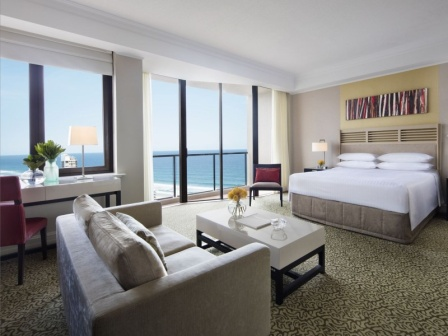Imagine the carpet in this room comes to life. What adventures might it lead to? As the clock strikes midnight, the black and white patterned carpet begins to shimmer with a mystical glow. Tiny figures emerge from its intricate designs, inviting the room's guest to step onto the carpet. As they do, they are transported to an enchanted land where every step reveals a new adventure. From navigating magical forests to attending royal balls in shimmering castles, the carpet leads them through a whirlwind of fantastical experiences. Each night unveils a new chapter, with stories of bravery, friendship, and wonder, until dawn brings them back to the cozy hotel room, transformed by their nightly escapades. 